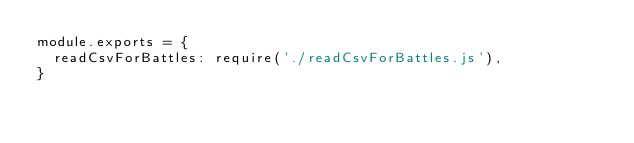Convert code to text. <code><loc_0><loc_0><loc_500><loc_500><_JavaScript_>module.exports = {
  readCsvForBattles: require('./readCsvForBattles.js'),
}</code> 